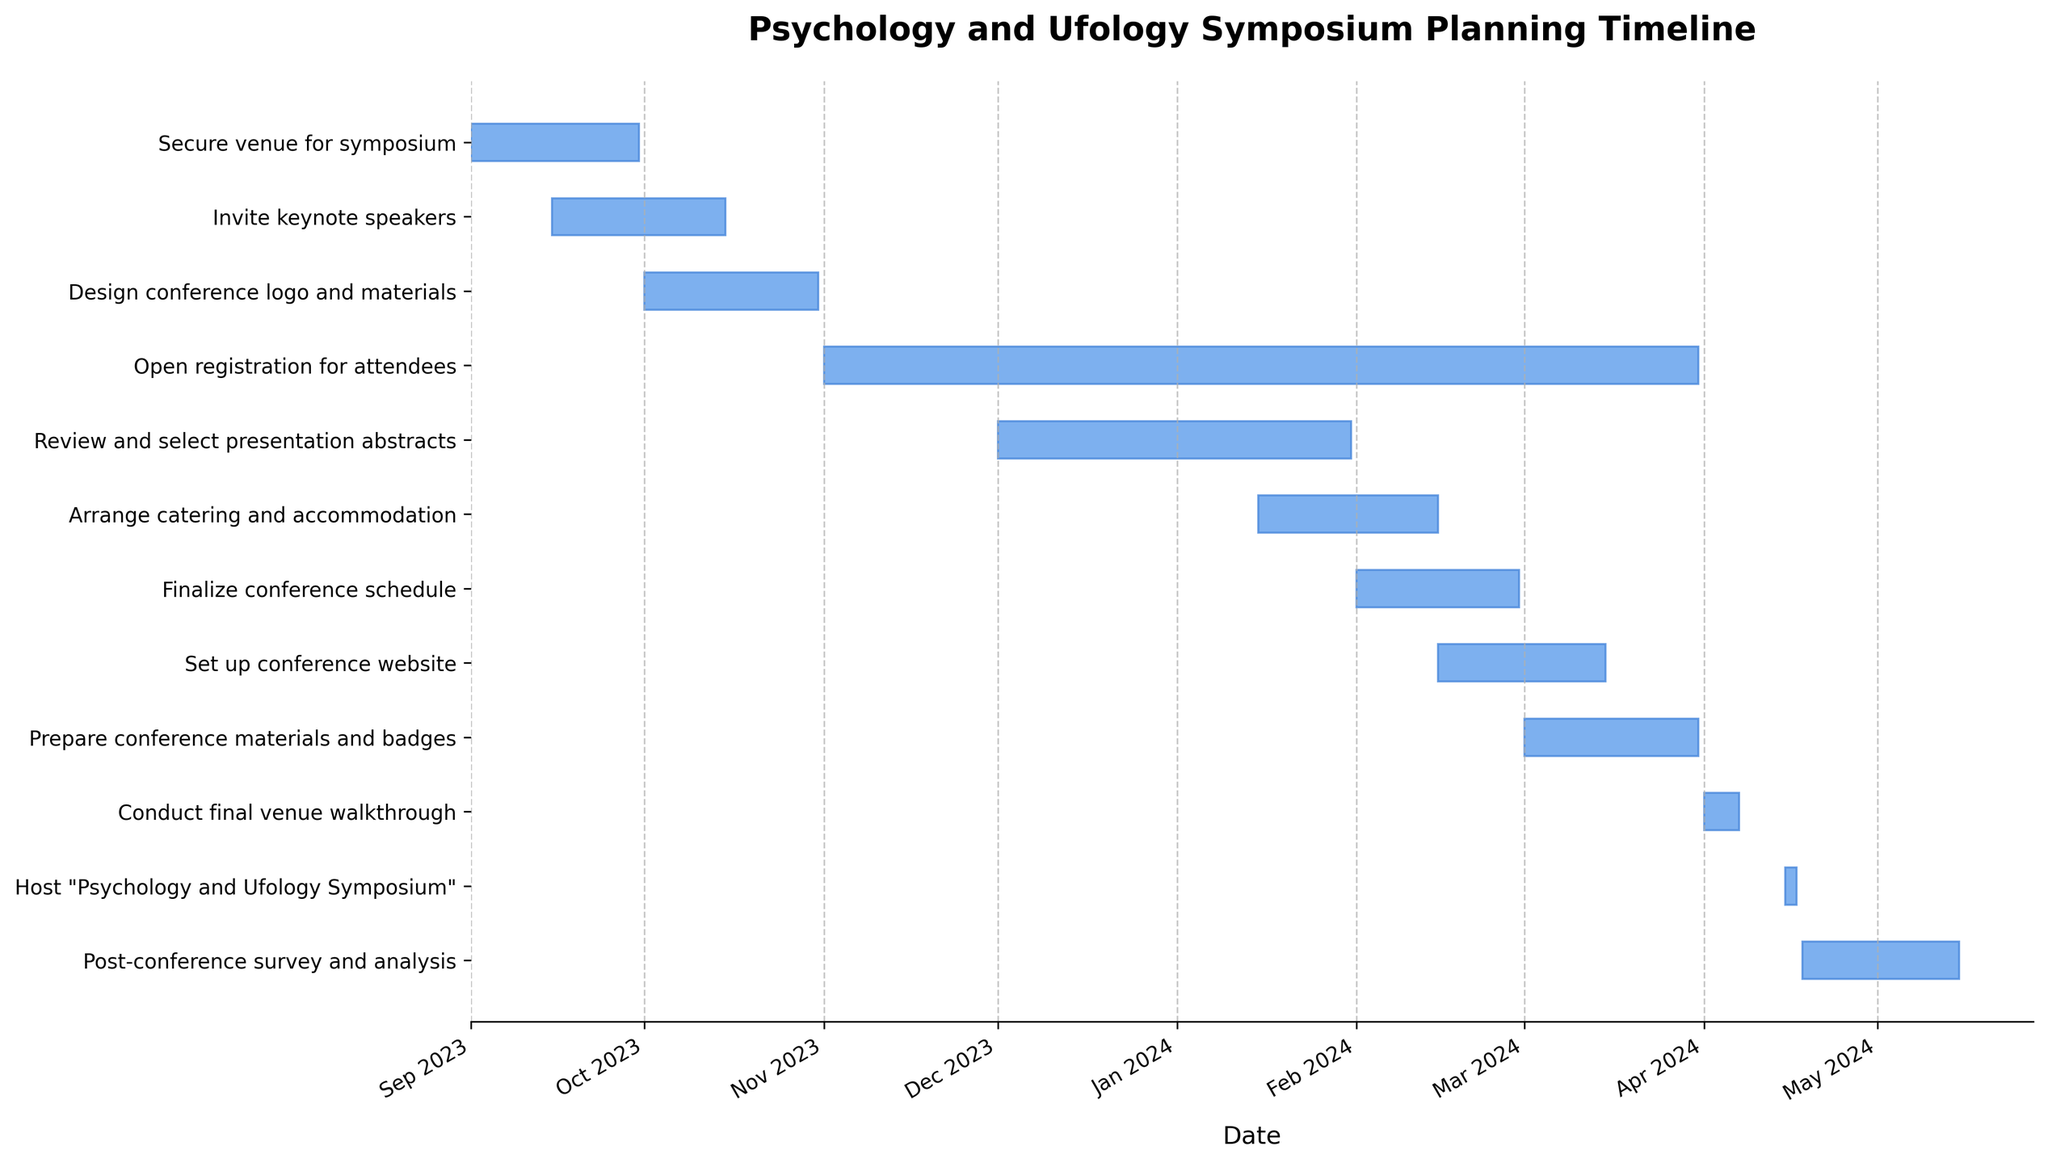What is the title of the Gantt Chart? The title is usually found at the top of the chart. It provides a brief description of what the Gantt Chart represents.
Answer: Psychology and Ufology Symposium Planning Timeline When does the task "Secure venue for symposium" start and end? By looking at the bar corresponding to this task on the Gantt Chart, check the start and end points on the date axis.
Answer: Starts on 2023-09-01 and ends on 2023-09-30 Which task has the longest duration? To find this, compare the lengths of all the bars representing each task. The bar with the longest length represents the task with the longest duration.
Answer: Open registration for attendees How long does the task "Open registration for attendees" take? Calculate the duration by subtracting the start date from the end date for the task "Open registration for attendees".
Answer: 151 days Which tasks are scheduled to start in January 2024? By examining the start points of the bars, identify the tasks whose start dates fall within January 2024.
Answer: Arrange catering and accommodation and Finalize conference schedule Are there any tasks that overlap with the task "Review and select presentation abstracts"? Check if any bars representing other tasks intersect with the bar for "Review and select presentation abstracts".
Answer: Yes, "Arrange catering and accommodation" How does the duration of "Invite keynote speakers" compare to that of "Review and select presentation abstracts"? Compare the lengths of the bars for the two tasks, or calculate the difference in their durations by subtracting the start date from the end date for each task and comparing the results.
Answer: "Invite keynote speakers" is 30 days, "Review and select presentation abstracts" is 61 days; "Review and select presentation abstracts" is longer During which month does the task "Set up conference website" start and end? Look at the start and end of the bar for "Set up conference website" and refer to the date labels on the x-axis.
Answer: Starts in February 2024 and ends in March 2024 Which two tasks are conducted closest to the symposium dates? Examine the timeline to see which tasks end nearest to the start of "Host 'Psychology and Ufology Symposium'" on April 15, 2024.
Answer: Prepare conference materials and badges and Conduct final venue walkthrough 